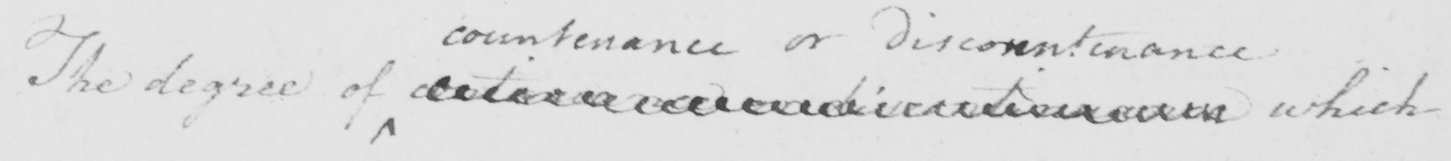Can you read and transcribe this handwriting? The degree of contenance or discontenance which 